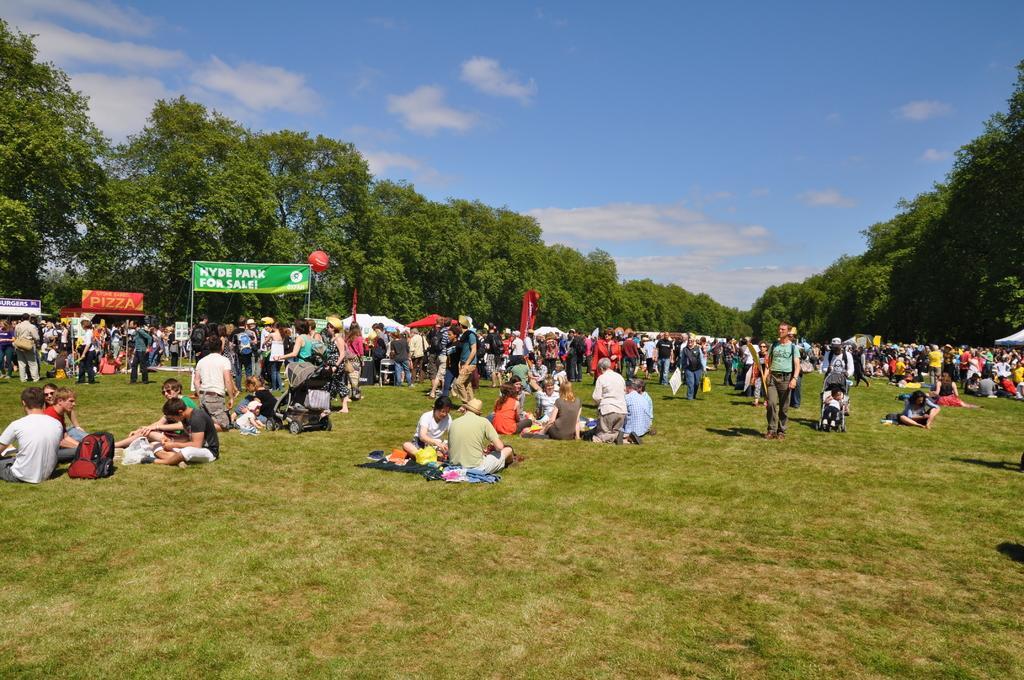How would you summarize this image in a sentence or two? In this image we can see a group of people and two trolleys on the ground. We can also see some grass, a banner to the poles, a balloon, the flags, sign boards, a group of trees, some tents and the sky which looks cloudy. 